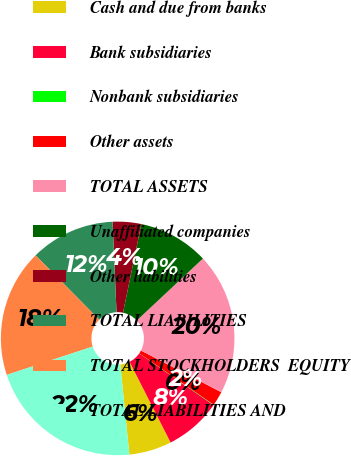Convert chart. <chart><loc_0><loc_0><loc_500><loc_500><pie_chart><fcel>Cash and due from banks<fcel>Bank subsidiaries<fcel>Nonbank subsidiaries<fcel>Other assets<fcel>TOTAL ASSETS<fcel>Unaffiliated companies<fcel>Other liabilities<fcel>TOTAL LIABILITIES<fcel>TOTAL STOCKHOLDERS EQUITY<fcel>TOTAL LIABILITIES AND<nl><fcel>5.89%<fcel>7.83%<fcel>0.06%<fcel>2.0%<fcel>19.6%<fcel>9.77%<fcel>3.94%<fcel>11.72%<fcel>17.65%<fcel>21.54%<nl></chart> 